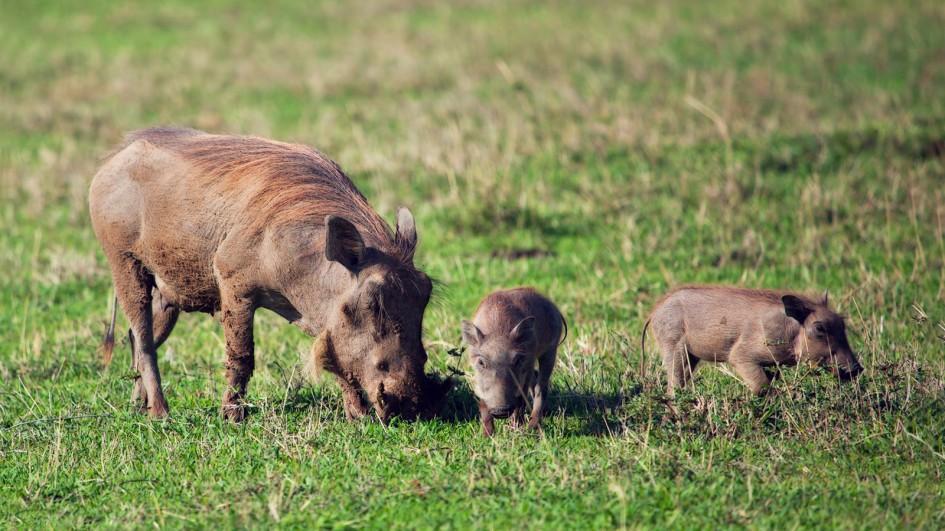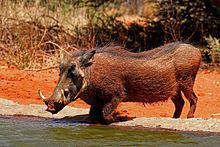The first image is the image on the left, the second image is the image on the right. For the images displayed, is the sentence "Three animals, including an adult warthog, are in the left image." factually correct? Answer yes or no. Yes. The first image is the image on the left, the second image is the image on the right. Given the left and right images, does the statement "A total of two animals are shown in a natural setting." hold true? Answer yes or no. No. 